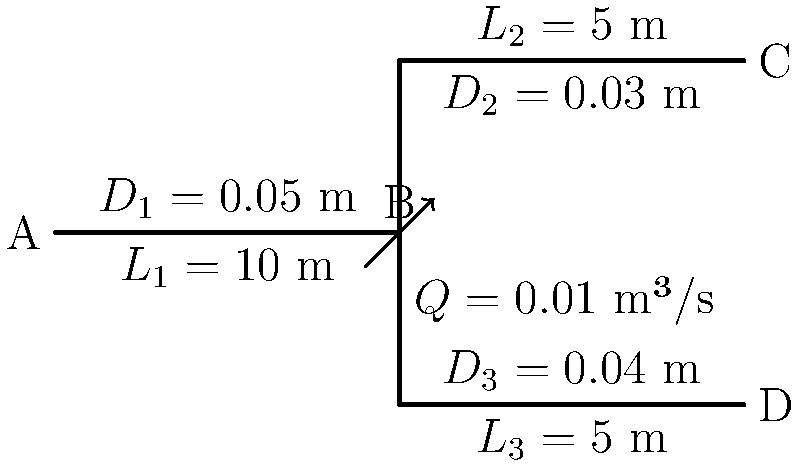As a proud alumnus of Aberystwyth University, you're tasked with analyzing a pipe network for a local engineering project. The network consists of three pipes with different diameters and lengths, as shown in the diagram. The total flow rate is $Q = 0.01$ m³/s, which splits equally between pipes 2 and 3. Assuming turbulent flow and a friction factor of $f = 0.02$ for all pipes, calculate the total pressure drop from point A to points C and D. Use the Darcy-Weisbach equation: $\Delta P = f \frac{L}{D} \frac{\rho v^2}{2}$, where $\rho = 1000$ kg/m³ for water. Round your answer to the nearest 100 Pa. Let's approach this step-by-step:

1) First, calculate the flow rates in each pipe:
   $Q_1 = 0.01$ m³/s
   $Q_2 = Q_3 = 0.005$ m³/s

2) Calculate velocities in each pipe using $v = \frac{Q}{A} = \frac{4Q}{\pi D^2}$:
   $v_1 = \frac{4(0.01)}{\pi(0.05)^2} = 5.09$ m/s
   $v_2 = \frac{4(0.005)}{\pi(0.03)^2} = 7.07$ m/s
   $v_3 = \frac{4(0.005)}{\pi(0.04)^2} = 3.98$ m/s

3) Use the Darcy-Weisbach equation to calculate pressure drops:
   $\Delta P_1 = 0.02 \cdot \frac{10}{0.05} \cdot \frac{1000 \cdot 5.09^2}{2} = 103,636$ Pa
   $\Delta P_2 = 0.02 \cdot \frac{5}{0.03} \cdot \frac{1000 \cdot 7.07^2}{2} = 83,156$ Pa
   $\Delta P_3 = 0.02 \cdot \frac{5}{0.04} \cdot \frac{1000 \cdot 3.98^2}{2} = 19,800$ Pa

4) The total pressure drop is the sum of $\Delta P_1$ and either $\Delta P_2$ or $\Delta P_3$:
   $\Delta P_{total} = \Delta P_1 + \Delta P_2 = 103,636 + 83,156 = 186,792$ Pa
   
   Or
   
   $\Delta P_{total} = \Delta P_1 + \Delta P_3 = 103,636 + 19,800 = 123,436$ Pa

5) Rounding to the nearest 100 Pa:
   $\Delta P_{total}$ (A to C) ≈ 186,800 Pa
   $\Delta P_{total}$ (A to D) ≈ 123,400 Pa
Answer: 186,800 Pa (A to C) and 123,400 Pa (A to D) 